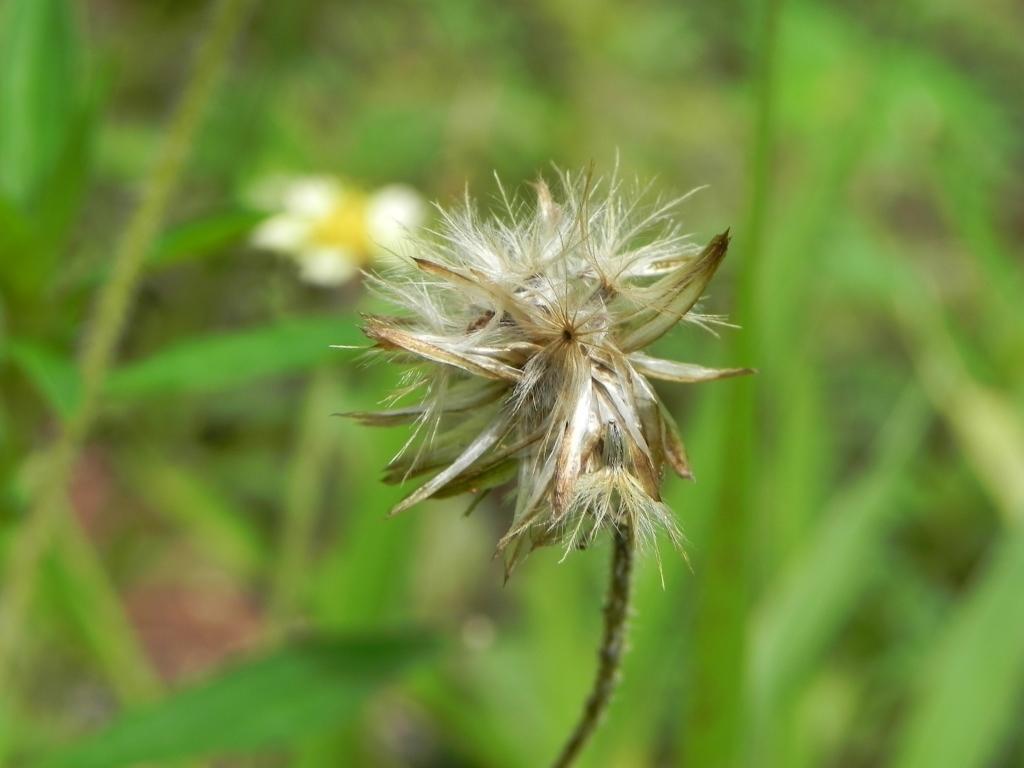Please provide a concise description of this image. In this image there are flowers, there are plants, there are plants truncated towards the right of the image, there are plants truncated towards the top of the image, there are plants truncated towards the left of the image, there are plants truncated towards the bottom of the image. 